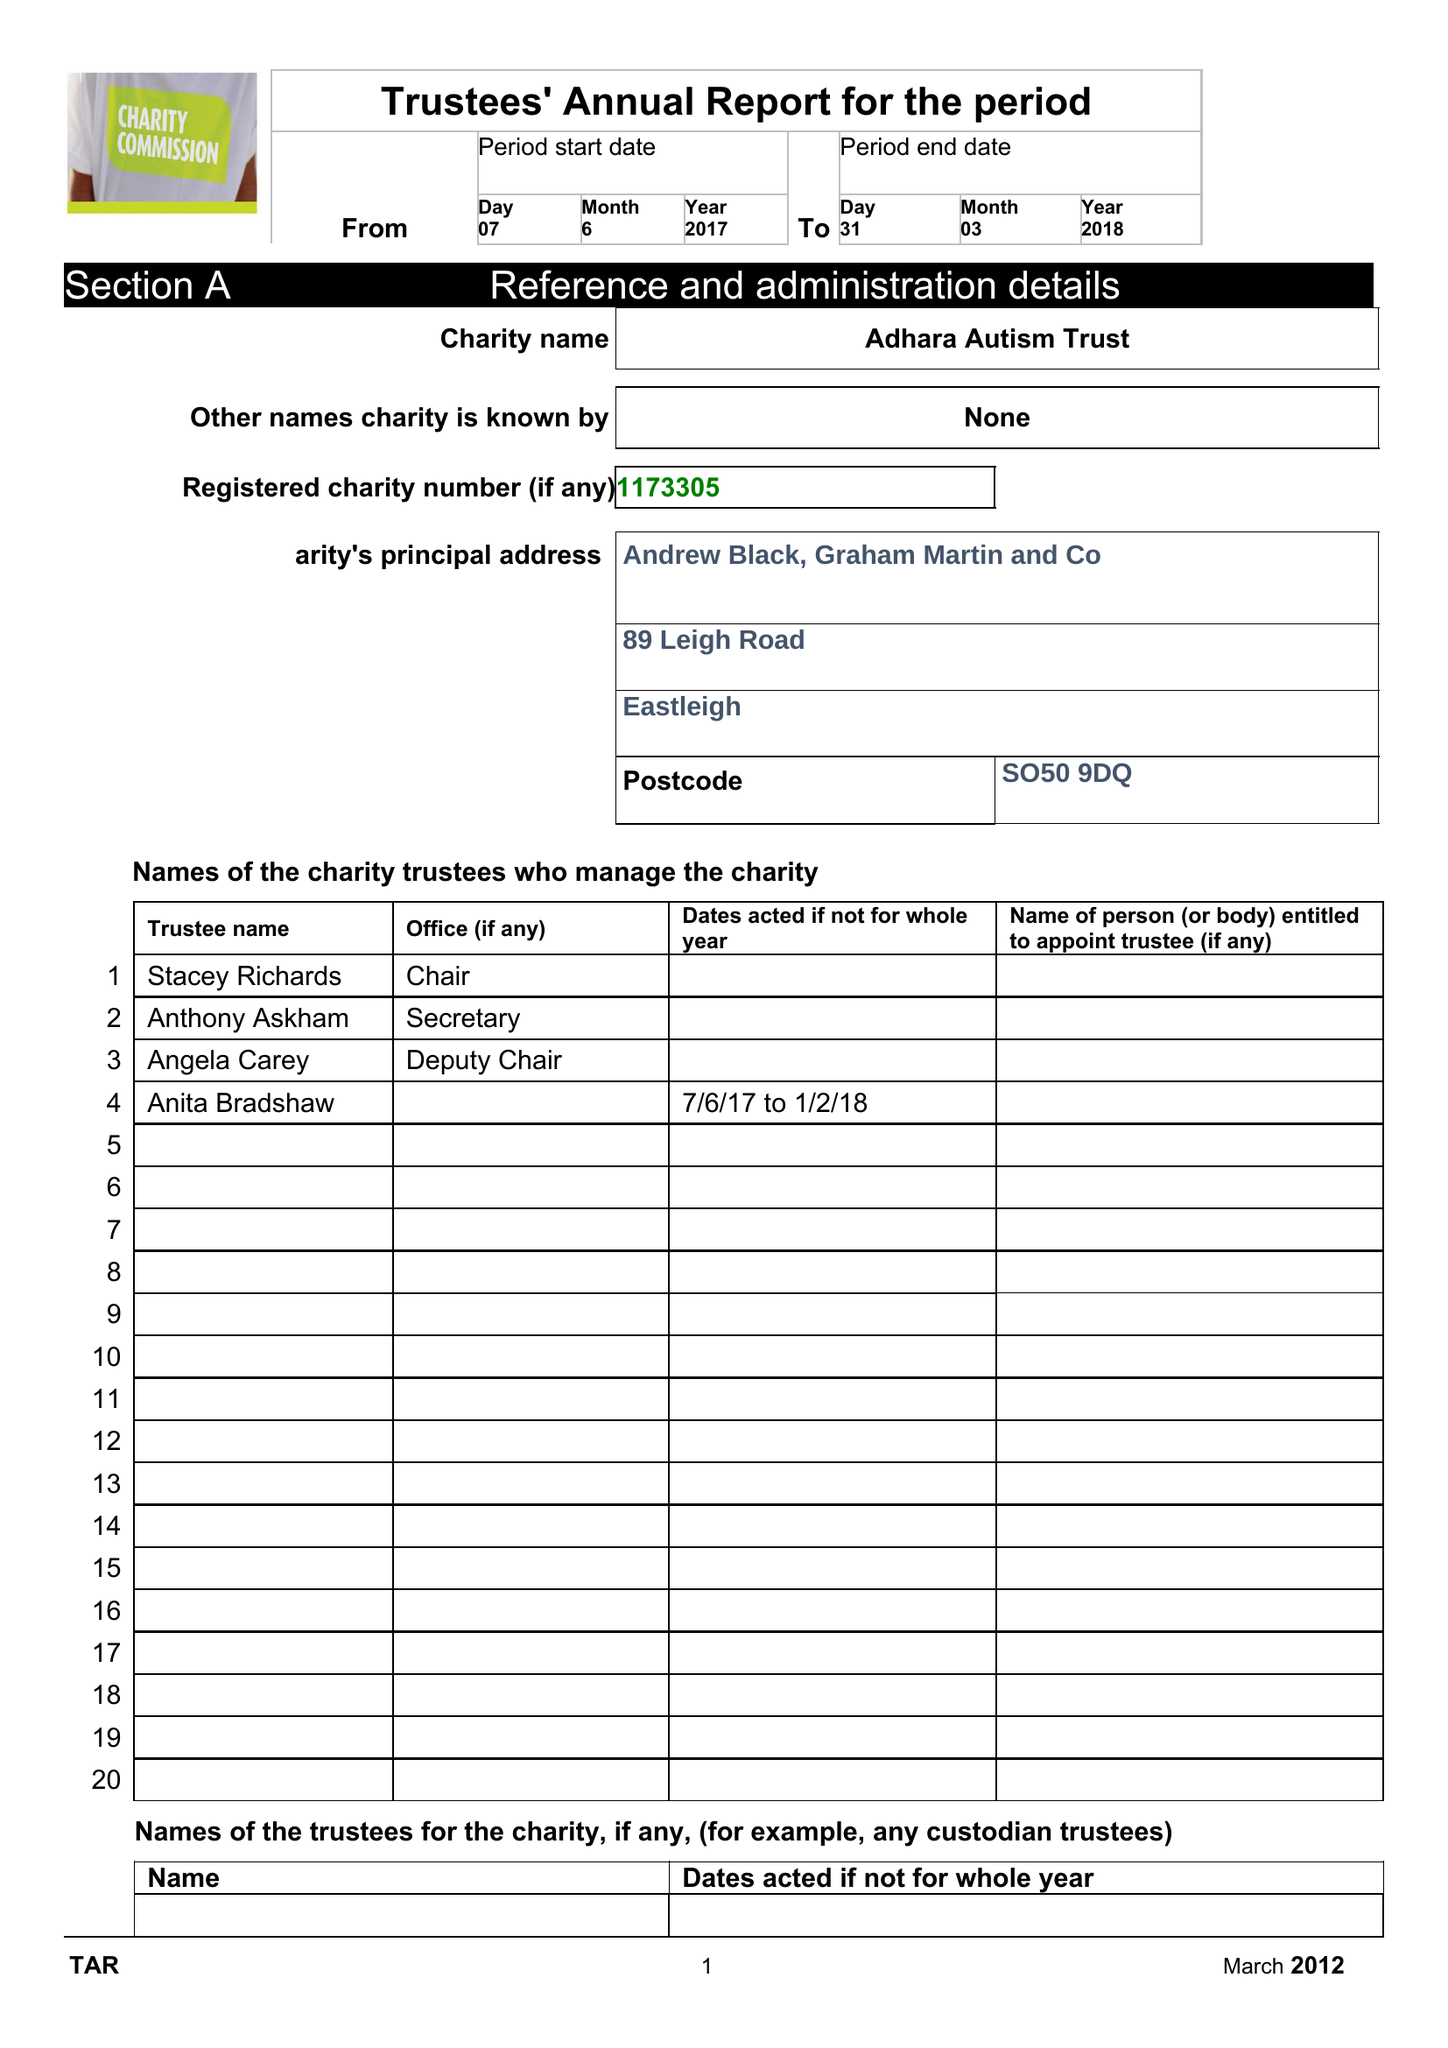What is the value for the address__post_town?
Answer the question using a single word or phrase. EASTLEIGH 